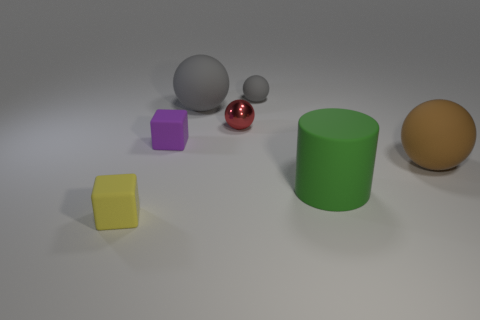Subtract all red metal balls. How many balls are left? 3 Subtract all yellow blocks. How many blocks are left? 1 Subtract all balls. How many objects are left? 3 Add 1 yellow metal blocks. How many objects exist? 8 Add 4 gray metallic cylinders. How many gray metallic cylinders exist? 4 Subtract 0 blue spheres. How many objects are left? 7 Subtract 1 spheres. How many spheres are left? 3 Subtract all gray cylinders. Subtract all gray blocks. How many cylinders are left? 1 Subtract all gray blocks. How many purple spheres are left? 0 Subtract all small purple objects. Subtract all big matte cylinders. How many objects are left? 5 